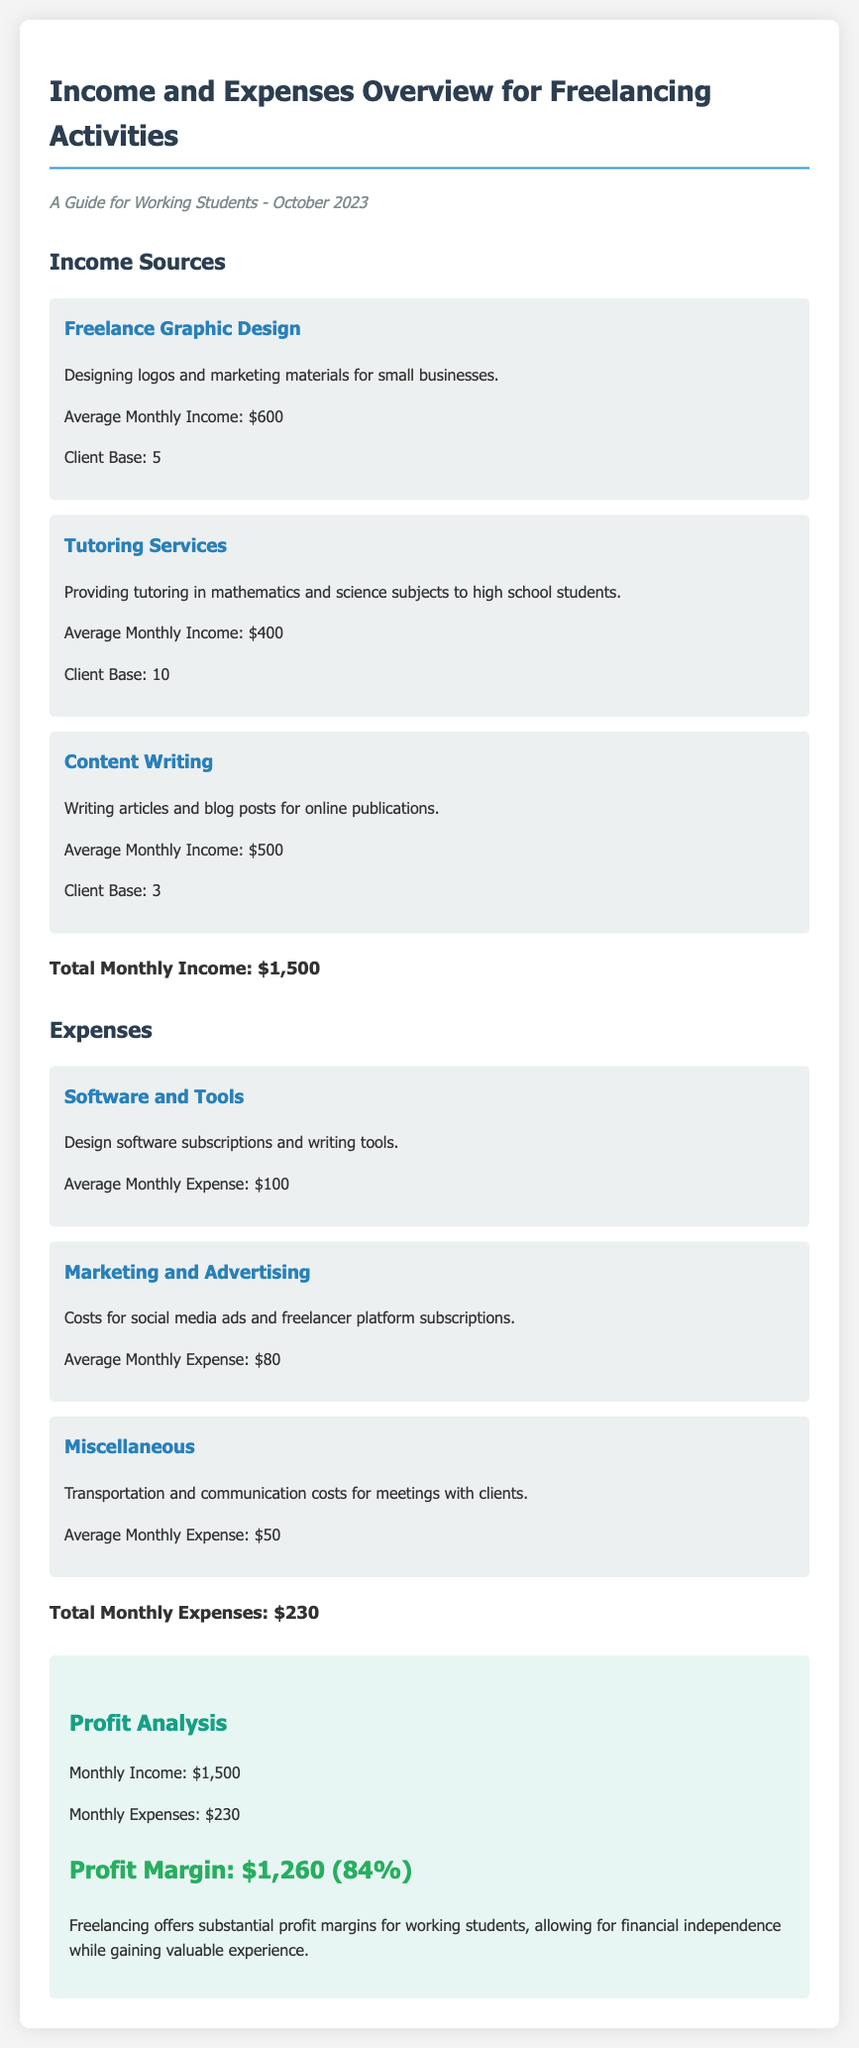What is the average monthly income from freelance graphic design? The average monthly income from freelance graphic design is specified in the document as $600.
Answer: $600 What is the total monthly expense? The total monthly expense is calculated from all expense categories in the document, which sums up to $230.
Answer: $230 What is the profit margin percentage? The profit margin percentage is calculated as profit divided by income, which is stated as 84% in the document.
Answer: 84% How many clients does the tutoring service cater to? The document mentions that the tutoring service has a client base of 10.
Answer: 10 What is the average monthly income from content writing? The average monthly income from content writing is detailed in the document as $500.
Answer: $500 What is the average monthly expense for software and tools? The document specifies the average monthly expense for software and tools as $100.
Answer: $100 Which income source has the highest earning? Freelance graphic design has the highest earning mentioned in the document with an average monthly income of $600.
Answer: Freelance Graphic Design What are the total monthly earnings? The total monthly earnings are calculated by adding all income sources, which sums to $1,500 as mentioned in the document.
Answer: $1,500 